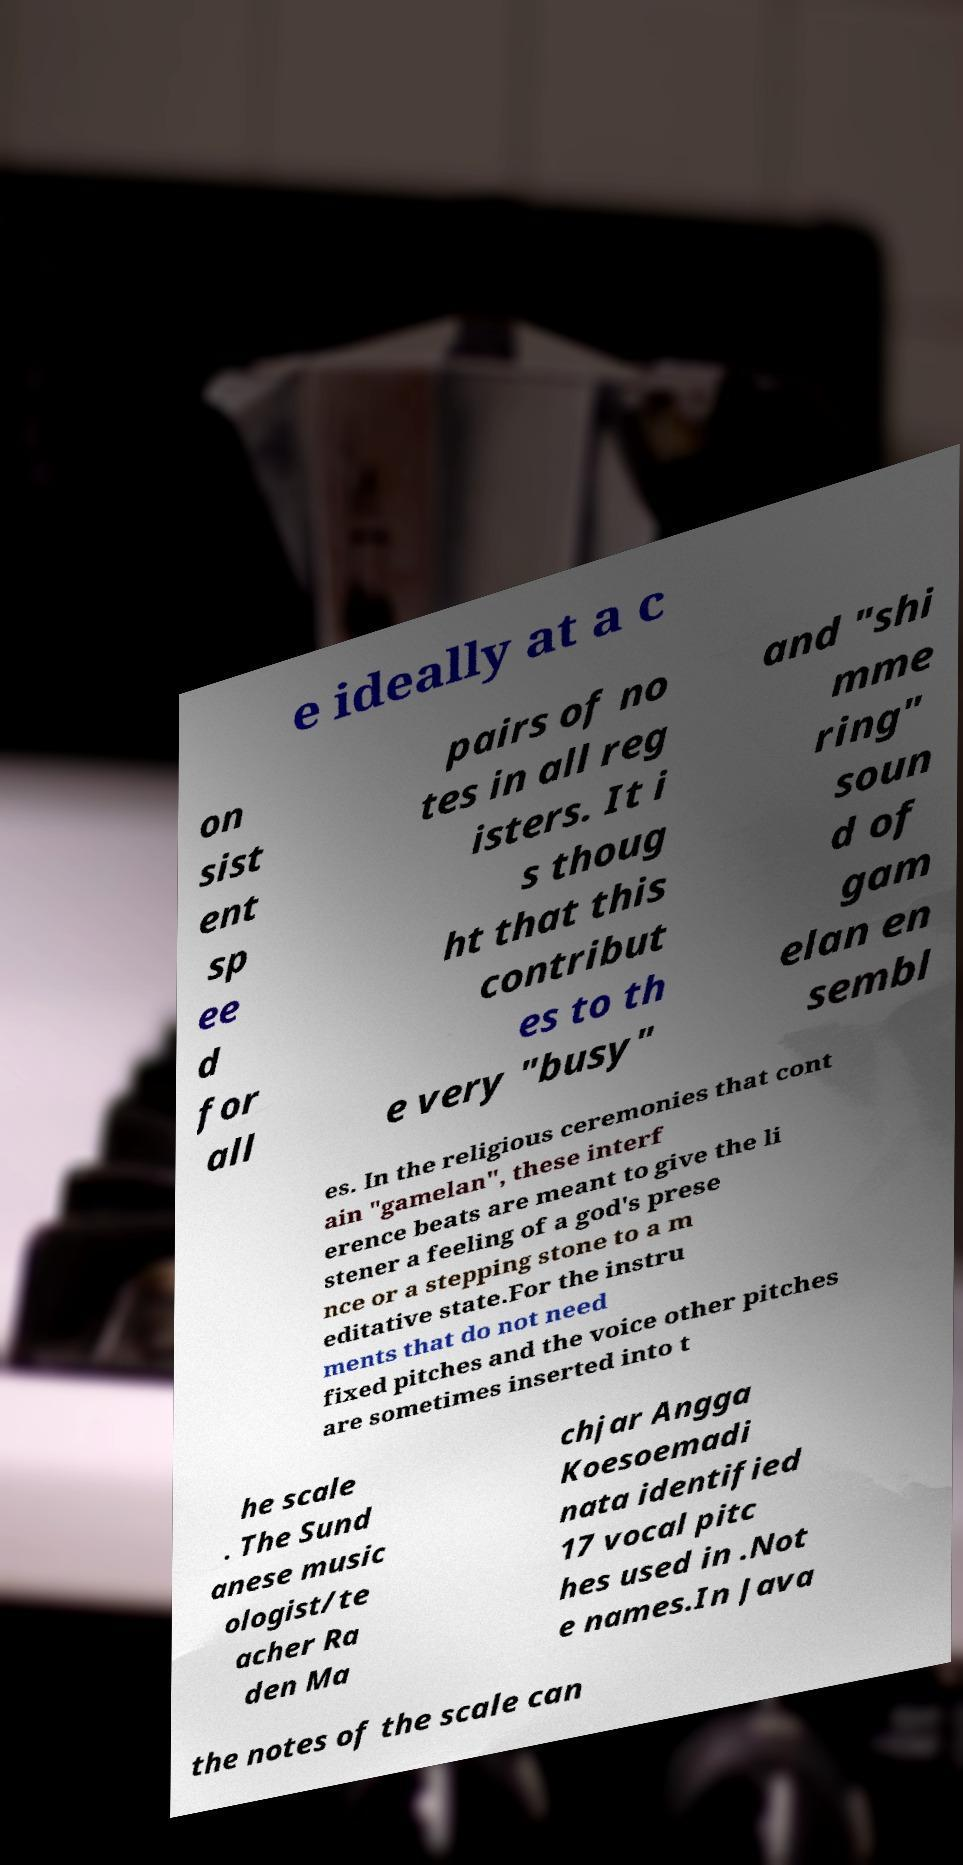There's text embedded in this image that I need extracted. Can you transcribe it verbatim? e ideally at a c on sist ent sp ee d for all pairs of no tes in all reg isters. It i s thoug ht that this contribut es to th e very "busy" and "shi mme ring" soun d of gam elan en sembl es. In the religious ceremonies that cont ain "gamelan", these interf erence beats are meant to give the li stener a feeling of a god's prese nce or a stepping stone to a m editative state.For the instru ments that do not need fixed pitches and the voice other pitches are sometimes inserted into t he scale . The Sund anese music ologist/te acher Ra den Ma chjar Angga Koesoemadi nata identified 17 vocal pitc hes used in .Not e names.In Java the notes of the scale can 